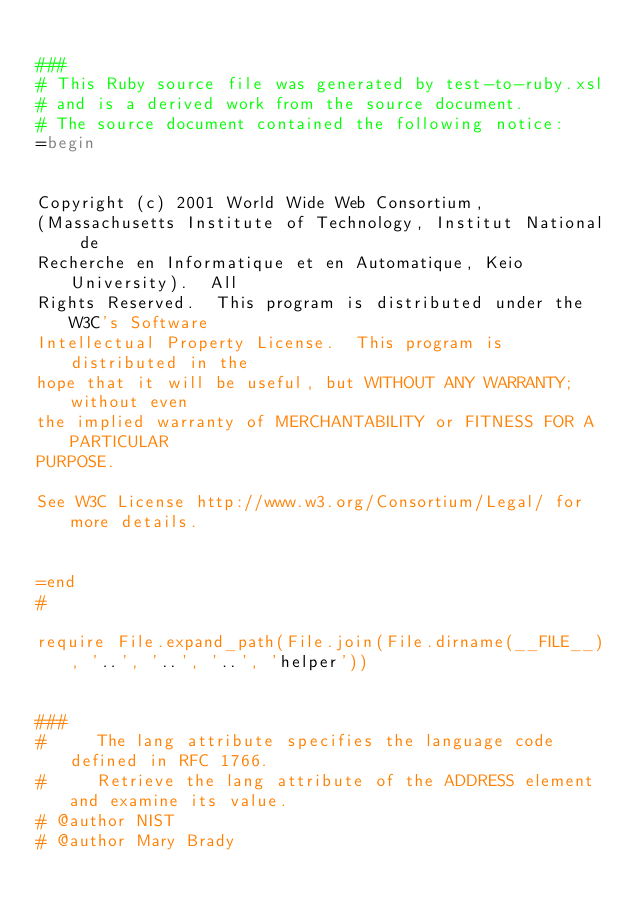<code> <loc_0><loc_0><loc_500><loc_500><_Ruby_>
###
# This Ruby source file was generated by test-to-ruby.xsl
# and is a derived work from the source document.
# The source document contained the following notice:
=begin


Copyright (c) 2001 World Wide Web Consortium, 
(Massachusetts Institute of Technology, Institut National de
Recherche en Informatique et en Automatique, Keio University).  All 
Rights Reserved.  This program is distributed under the W3C's Software
Intellectual Property License.  This program is distributed in the 
hope that it will be useful, but WITHOUT ANY WARRANTY; without even
the implied warranty of MERCHANTABILITY or FITNESS FOR A PARTICULAR 
PURPOSE.  

See W3C License http://www.w3.org/Consortium/Legal/ for more details.


=end
#

require File.expand_path(File.join(File.dirname(__FILE__), '..', '..', '..', 'helper'))


###
#     The lang attribute specifies the language code defined in RFC 1766. 
#     Retrieve the lang attribute of the ADDRESS element and examine its value.  
# @author NIST
# @author Mary Brady</code> 